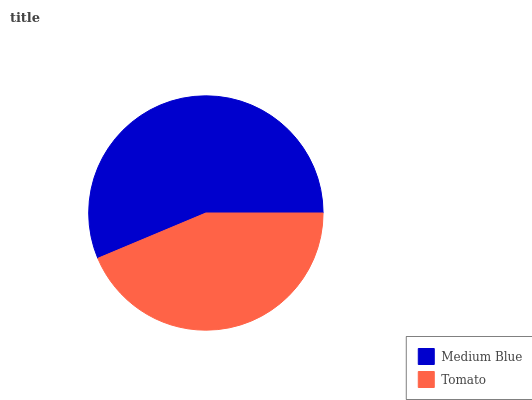Is Tomato the minimum?
Answer yes or no. Yes. Is Medium Blue the maximum?
Answer yes or no. Yes. Is Tomato the maximum?
Answer yes or no. No. Is Medium Blue greater than Tomato?
Answer yes or no. Yes. Is Tomato less than Medium Blue?
Answer yes or no. Yes. Is Tomato greater than Medium Blue?
Answer yes or no. No. Is Medium Blue less than Tomato?
Answer yes or no. No. Is Medium Blue the high median?
Answer yes or no. Yes. Is Tomato the low median?
Answer yes or no. Yes. Is Tomato the high median?
Answer yes or no. No. Is Medium Blue the low median?
Answer yes or no. No. 